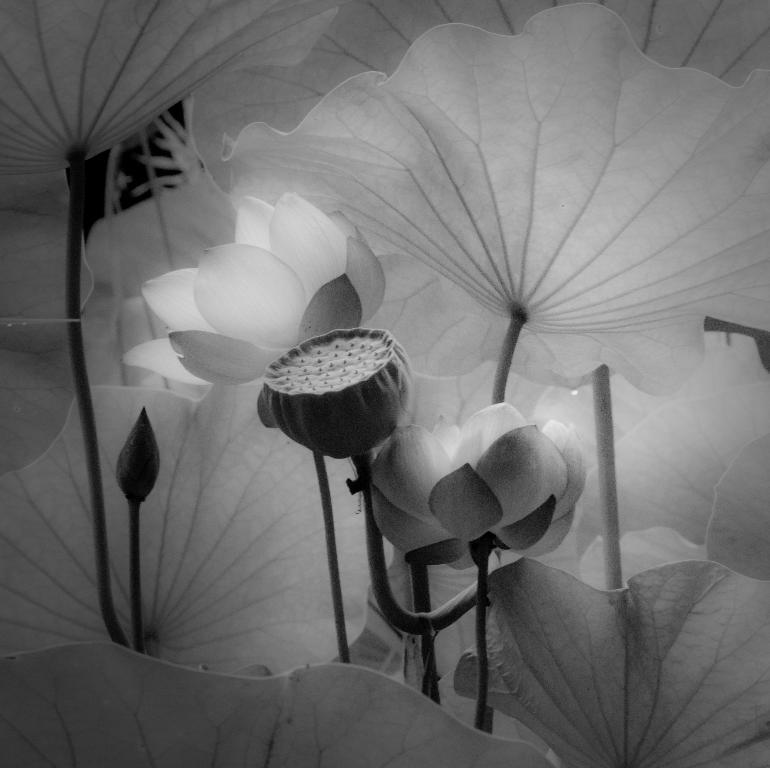What is the main subject of the image? The main subject of the image is flowers. Can you describe the flowers in the image? There are lots of flowers in the image. Is there any indication of a flower's growth stage in the image? Yes, there is a bud in the image. How many bricks are visible in the image? There are no bricks present in the image; it features flowers and a bud. What type of ants can be seen crawling on the flowers in the image? There are no ants present in the image; it only features flowers and a bud. 